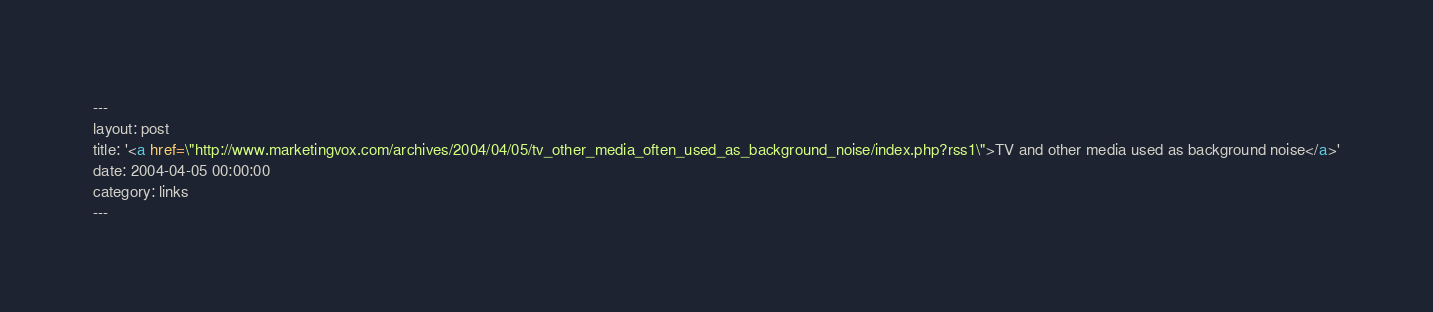Convert code to text. <code><loc_0><loc_0><loc_500><loc_500><_HTML_>---
layout: post
title: '<a href=\"http://www.marketingvox.com/archives/2004/04/05/tv_other_media_often_used_as_background_noise/index.php?rss1\">TV and other media used as background noise</a>'
date: 2004-04-05 00:00:00
category: links
---


</code> 